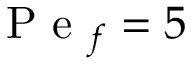Convert formula to latex. <formula><loc_0><loc_0><loc_500><loc_500>P e _ { f } = 5</formula> 